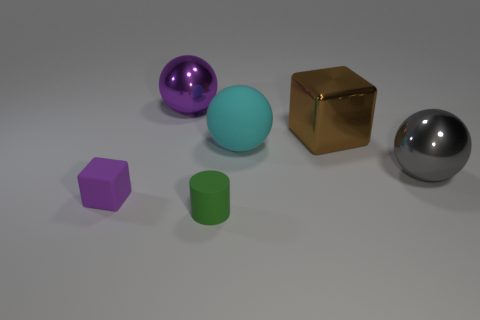How many yellow metal objects are the same size as the purple shiny object?
Your answer should be very brief. 0. What number of large gray metallic objects have the same shape as the large purple thing?
Ensure brevity in your answer.  1. Are there the same number of large blocks that are in front of the large gray shiny object and small matte cylinders?
Make the answer very short. No. The purple thing that is the same size as the gray object is what shape?
Give a very brief answer. Sphere. Are there any big metallic things that have the same shape as the small purple matte thing?
Offer a terse response. Yes. Is there a large metallic object in front of the big metal object behind the cube that is behind the big gray thing?
Give a very brief answer. Yes. Is the number of brown metal objects that are behind the tiny purple block greater than the number of cyan things that are behind the big purple shiny object?
Provide a succinct answer. Yes. There is a brown object that is the same size as the gray shiny thing; what material is it?
Your response must be concise. Metal. What number of large objects are gray metal things or cyan rubber balls?
Provide a short and direct response. 2. Does the purple metal object have the same shape as the small green matte thing?
Your response must be concise. No. 